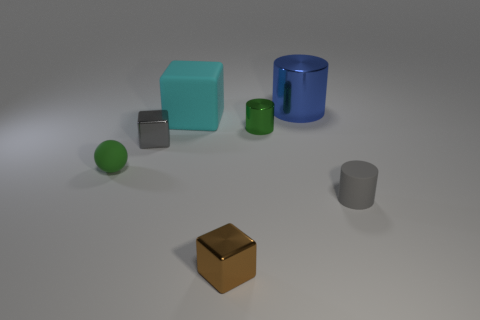Add 3 small green objects. How many objects exist? 10 Subtract all cubes. How many objects are left? 4 Add 7 brown shiny blocks. How many brown shiny blocks exist? 8 Subtract 0 red cubes. How many objects are left? 7 Subtract all small metal blocks. Subtract all green metallic balls. How many objects are left? 5 Add 4 cylinders. How many cylinders are left? 7 